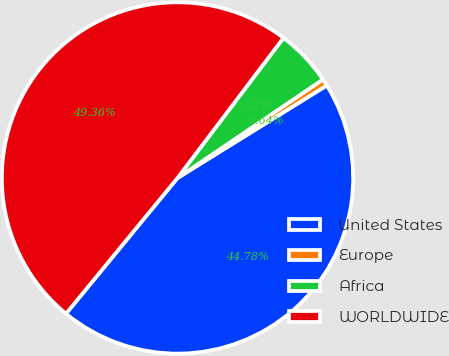<chart> <loc_0><loc_0><loc_500><loc_500><pie_chart><fcel>United States<fcel>Europe<fcel>Africa<fcel>WORLDWIDE<nl><fcel>44.78%<fcel>0.64%<fcel>5.22%<fcel>49.36%<nl></chart> 